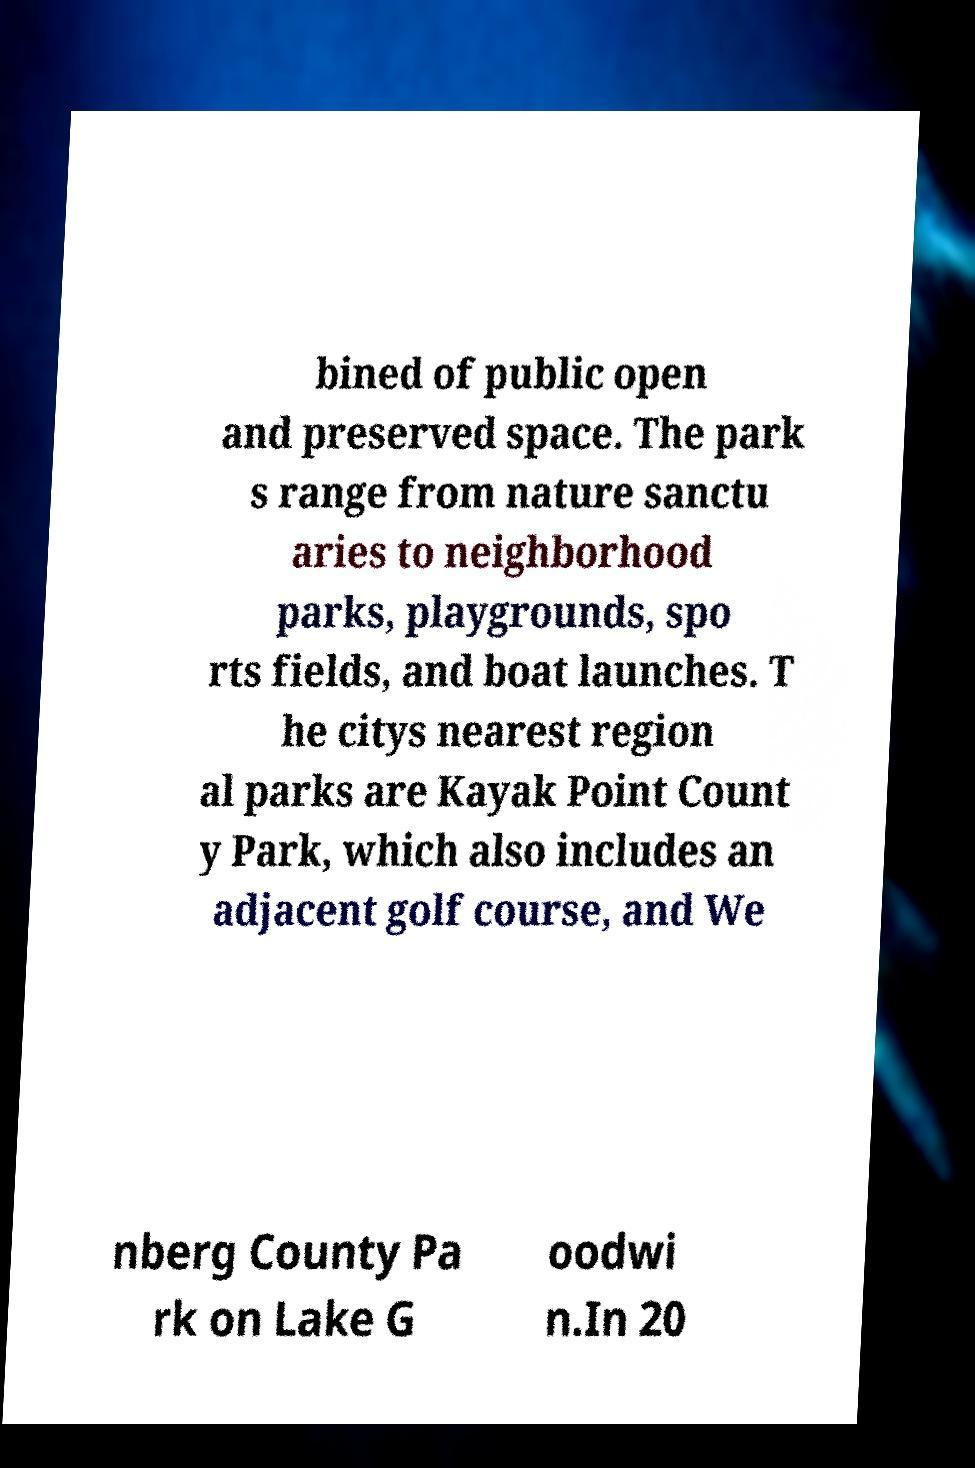Can you read and provide the text displayed in the image?This photo seems to have some interesting text. Can you extract and type it out for me? bined of public open and preserved space. The park s range from nature sanctu aries to neighborhood parks, playgrounds, spo rts fields, and boat launches. T he citys nearest region al parks are Kayak Point Count y Park, which also includes an adjacent golf course, and We nberg County Pa rk on Lake G oodwi n.In 20 